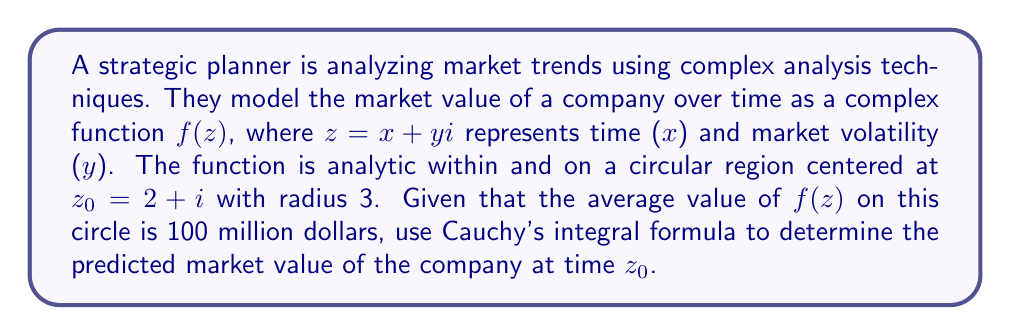What is the answer to this math problem? To solve this problem, we'll use Cauchy's integral formula and the mean value property of analytic functions. Let's break it down step by step:

1) Cauchy's integral formula states that for an analytic function $f(z)$ inside and on a simple closed contour $C$, and for any point $a$ inside $C$:

   $$f(a) = \frac{1}{2\pi i} \oint_C \frac{f(z)}{z-a} dz$$

2) In our case, $a = z_0 = 2+i$, and $C$ is the circle with center $z_0$ and radius 3.

3) The mean value property of analytic functions states that the average value of an analytic function on a circle is equal to the value of the function at the center of the circle. Mathematically:

   $$f(z_0) = \frac{1}{2\pi r} \oint_C f(z) dz$$

   where $r$ is the radius of the circle.

4) We're given that the average value of $f(z)$ on the circle is 100 million dollars. This means:

   $$100 = \frac{1}{2\pi 3} \oint_C f(z) dz$$

5) Multiplying both sides by $2\pi 3$:

   $$600\pi = \oint_C f(z) dz$$

6) Now, let's consider Cauchy's integral formula again. We can rewrite it as:

   $$f(z_0) = \frac{1}{2\pi i} \oint_C \frac{f(z)}{z-(2+i)} dz$$

7) Notice that on our circle, $z-(2+i) = 3e^{i\theta}$ (since any point on the circle can be represented as $z_0 + 3e^{i\theta}$). Substituting this:

   $$f(z_0) = \frac{1}{2\pi i} \oint_C \frac{f(z)}{3e^{i\theta}} dz = \frac{1}{6\pi i} \oint_C f(z) dz$$

8) We found in step 5 that $\oint_C f(z) dz = 600\pi$. Substituting this:

   $$f(z_0) = \frac{1}{6\pi i} (600\pi) = 100i$$

Therefore, the predicted market value of the company at time $z_0$ is 100i million dollars.
Answer: The predicted market value of the company at time $z_0$ is $100i$ million dollars. 